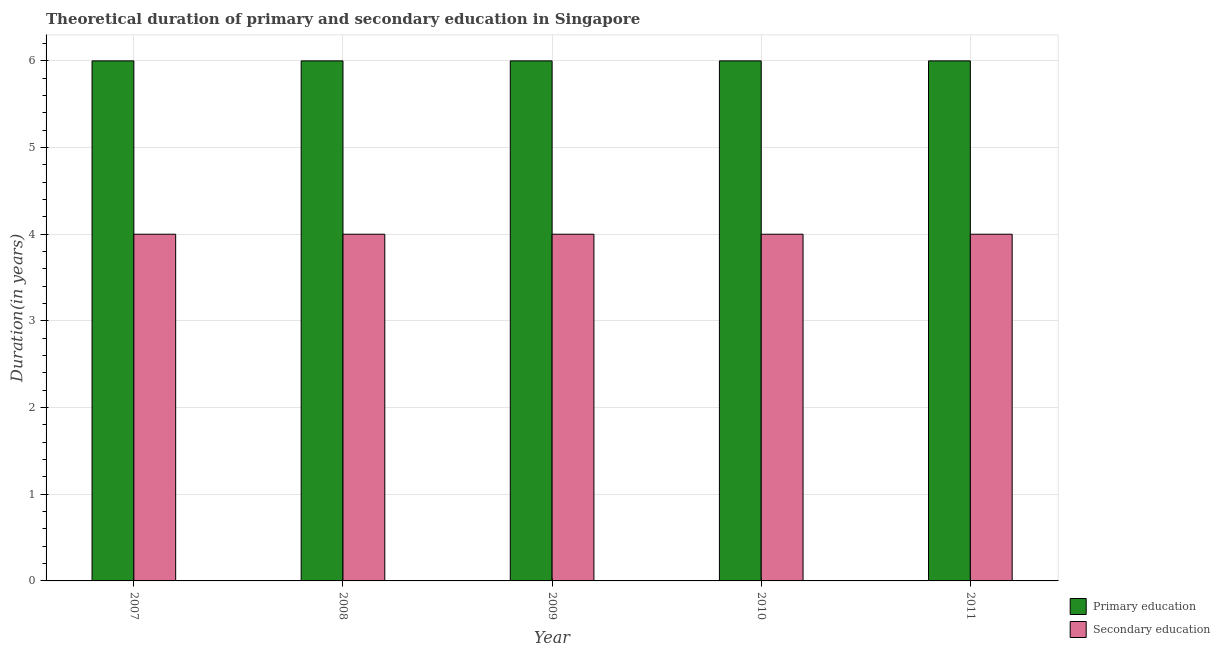Are the number of bars per tick equal to the number of legend labels?
Your answer should be compact. Yes. Are the number of bars on each tick of the X-axis equal?
Offer a very short reply. Yes. How many bars are there on the 4th tick from the right?
Provide a succinct answer. 2. What is the duration of primary education in 2008?
Your answer should be very brief. 6. Across all years, what is the maximum duration of secondary education?
Make the answer very short. 4. Across all years, what is the minimum duration of primary education?
Offer a terse response. 6. In which year was the duration of primary education maximum?
Offer a terse response. 2007. What is the total duration of secondary education in the graph?
Make the answer very short. 20. In the year 2009, what is the difference between the duration of secondary education and duration of primary education?
Offer a very short reply. 0. In how many years, is the duration of primary education greater than 3.2 years?
Ensure brevity in your answer.  5. What is the ratio of the duration of secondary education in 2007 to that in 2008?
Provide a short and direct response. 1. Is the duration of secondary education in 2007 less than that in 2011?
Your answer should be compact. No. What is the difference between the highest and the second highest duration of primary education?
Keep it short and to the point. 0. What is the difference between the highest and the lowest duration of primary education?
Provide a short and direct response. 0. In how many years, is the duration of secondary education greater than the average duration of secondary education taken over all years?
Provide a short and direct response. 0. Is the sum of the duration of primary education in 2009 and 2011 greater than the maximum duration of secondary education across all years?
Give a very brief answer. Yes. What does the 2nd bar from the left in 2008 represents?
Provide a short and direct response. Secondary education. What does the 2nd bar from the right in 2011 represents?
Your answer should be very brief. Primary education. How many bars are there?
Offer a very short reply. 10. Are all the bars in the graph horizontal?
Your answer should be very brief. No. Does the graph contain grids?
Your response must be concise. Yes. Where does the legend appear in the graph?
Provide a short and direct response. Bottom right. How many legend labels are there?
Make the answer very short. 2. What is the title of the graph?
Give a very brief answer. Theoretical duration of primary and secondary education in Singapore. Does "Health Care" appear as one of the legend labels in the graph?
Ensure brevity in your answer.  No. What is the label or title of the X-axis?
Your answer should be compact. Year. What is the label or title of the Y-axis?
Offer a very short reply. Duration(in years). What is the Duration(in years) of Primary education in 2007?
Offer a terse response. 6. What is the Duration(in years) in Secondary education in 2007?
Offer a very short reply. 4. What is the Duration(in years) of Primary education in 2008?
Provide a short and direct response. 6. What is the Duration(in years) in Primary education in 2009?
Make the answer very short. 6. What is the Duration(in years) of Secondary education in 2009?
Ensure brevity in your answer.  4. What is the Duration(in years) of Primary education in 2010?
Provide a succinct answer. 6. What is the Duration(in years) in Secondary education in 2010?
Provide a short and direct response. 4. What is the Duration(in years) of Secondary education in 2011?
Your answer should be compact. 4. Across all years, what is the maximum Duration(in years) in Primary education?
Offer a terse response. 6. Across all years, what is the maximum Duration(in years) of Secondary education?
Offer a terse response. 4. Across all years, what is the minimum Duration(in years) of Primary education?
Offer a terse response. 6. What is the total Duration(in years) of Secondary education in the graph?
Make the answer very short. 20. What is the difference between the Duration(in years) of Primary education in 2007 and that in 2008?
Offer a terse response. 0. What is the difference between the Duration(in years) in Secondary education in 2007 and that in 2008?
Give a very brief answer. 0. What is the difference between the Duration(in years) in Secondary education in 2007 and that in 2010?
Your answer should be very brief. 0. What is the difference between the Duration(in years) of Primary education in 2007 and that in 2011?
Make the answer very short. 0. What is the difference between the Duration(in years) in Secondary education in 2007 and that in 2011?
Provide a short and direct response. 0. What is the difference between the Duration(in years) in Secondary education in 2008 and that in 2010?
Give a very brief answer. 0. What is the difference between the Duration(in years) of Secondary education in 2009 and that in 2010?
Your response must be concise. 0. What is the difference between the Duration(in years) of Primary education in 2009 and that in 2011?
Your response must be concise. 0. What is the difference between the Duration(in years) in Secondary education in 2010 and that in 2011?
Offer a terse response. 0. What is the difference between the Duration(in years) of Primary education in 2007 and the Duration(in years) of Secondary education in 2008?
Keep it short and to the point. 2. What is the difference between the Duration(in years) in Primary education in 2007 and the Duration(in years) in Secondary education in 2009?
Your response must be concise. 2. What is the difference between the Duration(in years) of Primary education in 2008 and the Duration(in years) of Secondary education in 2010?
Your answer should be compact. 2. What is the difference between the Duration(in years) in Primary education in 2009 and the Duration(in years) in Secondary education in 2010?
Ensure brevity in your answer.  2. What is the difference between the Duration(in years) in Primary education in 2009 and the Duration(in years) in Secondary education in 2011?
Make the answer very short. 2. In the year 2009, what is the difference between the Duration(in years) of Primary education and Duration(in years) of Secondary education?
Your response must be concise. 2. What is the ratio of the Duration(in years) in Primary education in 2007 to that in 2008?
Provide a succinct answer. 1. What is the ratio of the Duration(in years) of Primary education in 2007 to that in 2009?
Offer a terse response. 1. What is the ratio of the Duration(in years) in Primary education in 2007 to that in 2010?
Give a very brief answer. 1. What is the ratio of the Duration(in years) in Primary education in 2007 to that in 2011?
Your answer should be very brief. 1. What is the ratio of the Duration(in years) of Secondary education in 2007 to that in 2011?
Your response must be concise. 1. What is the ratio of the Duration(in years) of Secondary education in 2008 to that in 2011?
Give a very brief answer. 1. What is the ratio of the Duration(in years) of Primary education in 2009 to that in 2010?
Provide a succinct answer. 1. What is the ratio of the Duration(in years) in Primary education in 2009 to that in 2011?
Provide a short and direct response. 1. What is the ratio of the Duration(in years) in Secondary education in 2009 to that in 2011?
Offer a terse response. 1. What is the ratio of the Duration(in years) in Primary education in 2010 to that in 2011?
Keep it short and to the point. 1. What is the ratio of the Duration(in years) in Secondary education in 2010 to that in 2011?
Make the answer very short. 1. What is the difference between the highest and the second highest Duration(in years) in Secondary education?
Offer a terse response. 0. 